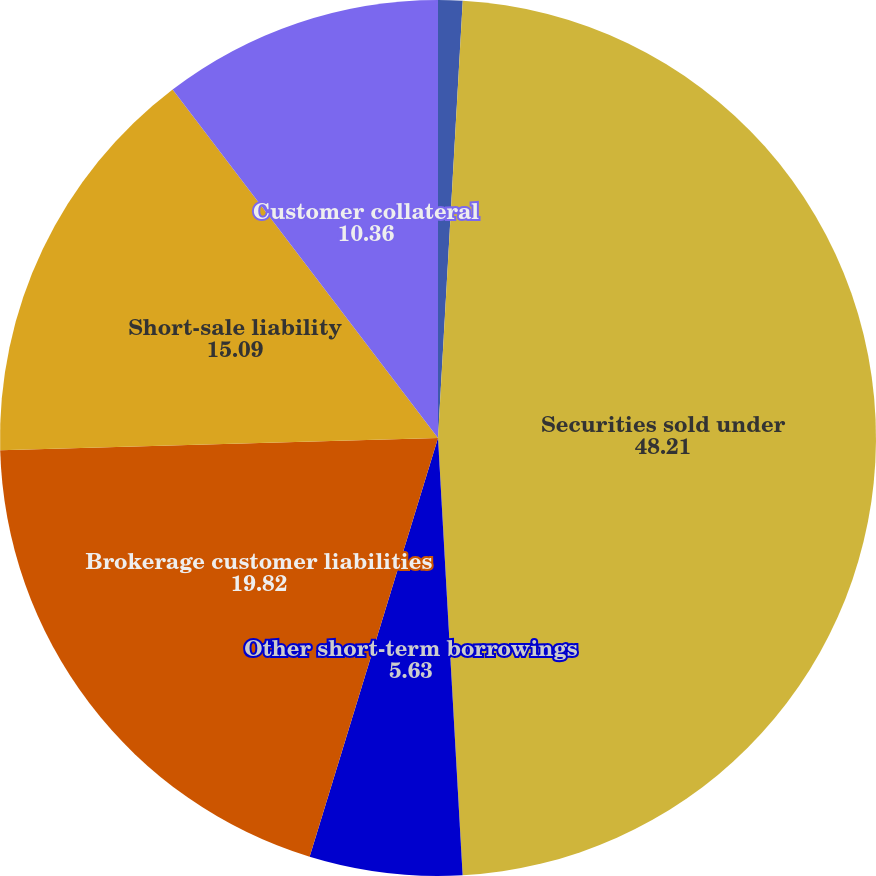Convert chart to OTSL. <chart><loc_0><loc_0><loc_500><loc_500><pie_chart><fcel>Federal funds purchased<fcel>Securities sold under<fcel>Other short-term borrowings<fcel>Brokerage customer liabilities<fcel>Short-sale liability<fcel>Customer collateral<nl><fcel>0.9%<fcel>48.21%<fcel>5.63%<fcel>19.82%<fcel>15.09%<fcel>10.36%<nl></chart> 